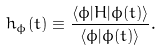<formula> <loc_0><loc_0><loc_500><loc_500>h _ { \phi } ( t ) \equiv \frac { \langle \phi | H | \phi ( t ) \rangle } { \langle \phi | \phi ( t ) \rangle } .</formula> 